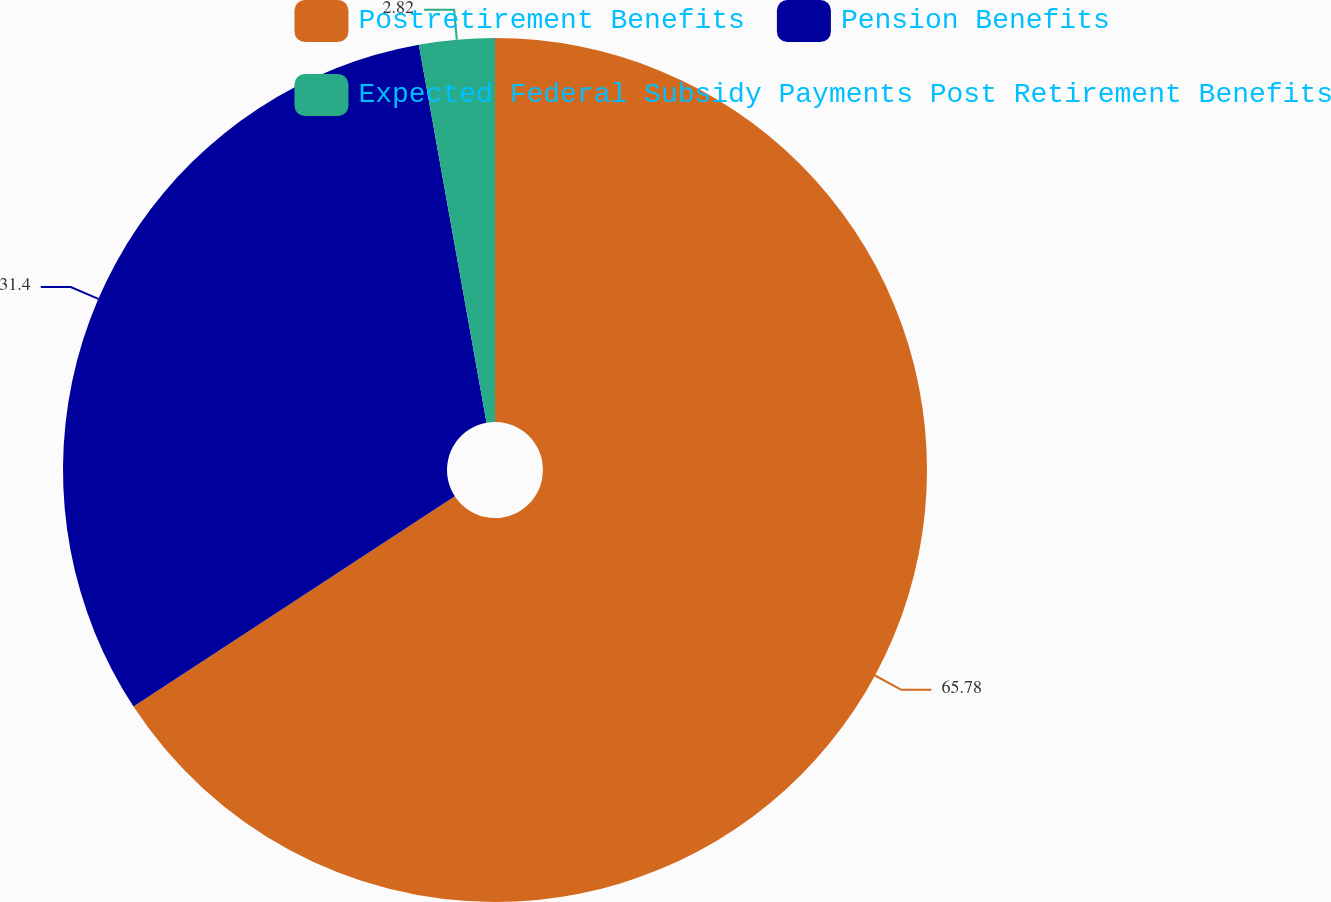Convert chart. <chart><loc_0><loc_0><loc_500><loc_500><pie_chart><fcel>Postretirement Benefits<fcel>Pension Benefits<fcel>Expected Federal Subsidy Payments Post Retirement Benefits<nl><fcel>65.78%<fcel>31.4%<fcel>2.82%<nl></chart> 